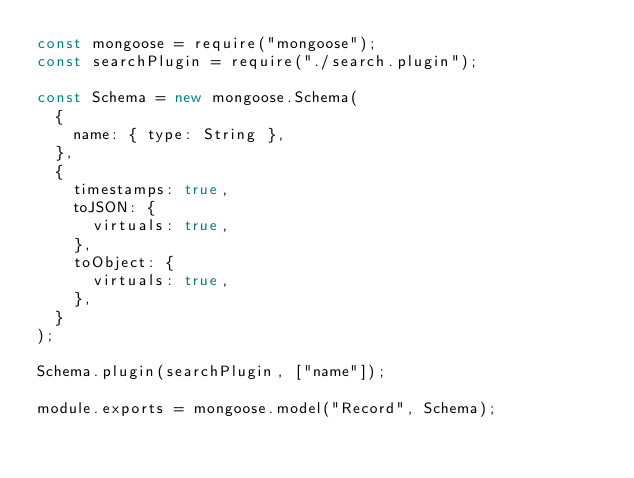Convert code to text. <code><loc_0><loc_0><loc_500><loc_500><_JavaScript_>const mongoose = require("mongoose");
const searchPlugin = require("./search.plugin");

const Schema = new mongoose.Schema(
  {
    name: { type: String },
  },
  {
    timestamps: true,
    toJSON: {
      virtuals: true,
    },
    toObject: {
      virtuals: true,
    },
  }
);

Schema.plugin(searchPlugin, ["name"]);

module.exports = mongoose.model("Record", Schema);
</code> 